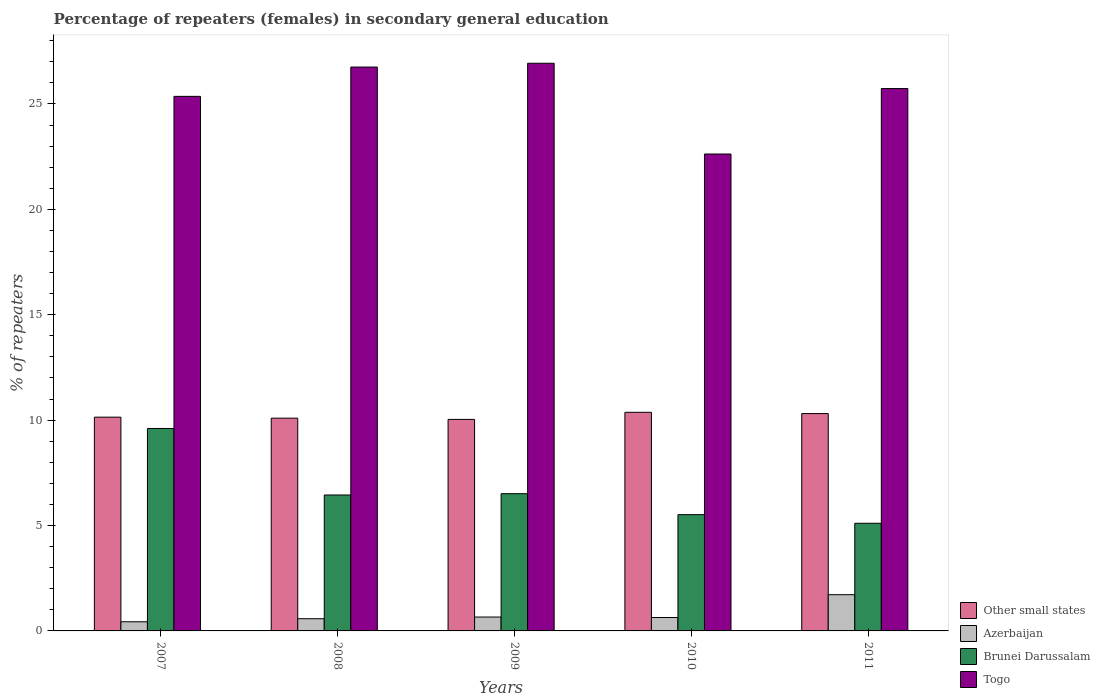How many groups of bars are there?
Ensure brevity in your answer.  5. Are the number of bars per tick equal to the number of legend labels?
Ensure brevity in your answer.  Yes. How many bars are there on the 1st tick from the left?
Offer a very short reply. 4. How many bars are there on the 2nd tick from the right?
Give a very brief answer. 4. In how many cases, is the number of bars for a given year not equal to the number of legend labels?
Offer a very short reply. 0. What is the percentage of female repeaters in Brunei Darussalam in 2009?
Your answer should be compact. 6.51. Across all years, what is the maximum percentage of female repeaters in Other small states?
Provide a succinct answer. 10.37. Across all years, what is the minimum percentage of female repeaters in Other small states?
Your answer should be very brief. 10.03. In which year was the percentage of female repeaters in Other small states minimum?
Ensure brevity in your answer.  2009. What is the total percentage of female repeaters in Azerbaijan in the graph?
Your response must be concise. 4.03. What is the difference between the percentage of female repeaters in Other small states in 2007 and that in 2010?
Keep it short and to the point. -0.23. What is the difference between the percentage of female repeaters in Togo in 2011 and the percentage of female repeaters in Azerbaijan in 2007?
Offer a terse response. 25.3. What is the average percentage of female repeaters in Other small states per year?
Your answer should be compact. 10.19. In the year 2008, what is the difference between the percentage of female repeaters in Other small states and percentage of female repeaters in Azerbaijan?
Make the answer very short. 9.51. What is the ratio of the percentage of female repeaters in Azerbaijan in 2007 to that in 2011?
Your answer should be compact. 0.25. Is the difference between the percentage of female repeaters in Other small states in 2008 and 2009 greater than the difference between the percentage of female repeaters in Azerbaijan in 2008 and 2009?
Provide a short and direct response. Yes. What is the difference between the highest and the second highest percentage of female repeaters in Azerbaijan?
Provide a short and direct response. 1.06. What is the difference between the highest and the lowest percentage of female repeaters in Other small states?
Offer a terse response. 0.34. Is the sum of the percentage of female repeaters in Azerbaijan in 2009 and 2011 greater than the maximum percentage of female repeaters in Togo across all years?
Offer a terse response. No. Is it the case that in every year, the sum of the percentage of female repeaters in Togo and percentage of female repeaters in Other small states is greater than the sum of percentage of female repeaters in Brunei Darussalam and percentage of female repeaters in Azerbaijan?
Your response must be concise. Yes. What does the 4th bar from the left in 2009 represents?
Provide a succinct answer. Togo. What does the 3rd bar from the right in 2007 represents?
Your answer should be very brief. Azerbaijan. Is it the case that in every year, the sum of the percentage of female repeaters in Other small states and percentage of female repeaters in Azerbaijan is greater than the percentage of female repeaters in Togo?
Provide a short and direct response. No. What is the difference between two consecutive major ticks on the Y-axis?
Make the answer very short. 5. Does the graph contain any zero values?
Offer a very short reply. No. Where does the legend appear in the graph?
Your answer should be very brief. Bottom right. How many legend labels are there?
Give a very brief answer. 4. How are the legend labels stacked?
Keep it short and to the point. Vertical. What is the title of the graph?
Your answer should be compact. Percentage of repeaters (females) in secondary general education. Does "Guatemala" appear as one of the legend labels in the graph?
Give a very brief answer. No. What is the label or title of the X-axis?
Make the answer very short. Years. What is the label or title of the Y-axis?
Ensure brevity in your answer.  % of repeaters. What is the % of repeaters in Other small states in 2007?
Your answer should be compact. 10.14. What is the % of repeaters of Azerbaijan in 2007?
Provide a short and direct response. 0.43. What is the % of repeaters in Brunei Darussalam in 2007?
Offer a terse response. 9.6. What is the % of repeaters in Togo in 2007?
Keep it short and to the point. 25.36. What is the % of repeaters of Other small states in 2008?
Your answer should be very brief. 10.09. What is the % of repeaters in Azerbaijan in 2008?
Offer a very short reply. 0.58. What is the % of repeaters in Brunei Darussalam in 2008?
Give a very brief answer. 6.45. What is the % of repeaters in Togo in 2008?
Offer a very short reply. 26.75. What is the % of repeaters of Other small states in 2009?
Your answer should be very brief. 10.03. What is the % of repeaters in Azerbaijan in 2009?
Your answer should be very brief. 0.66. What is the % of repeaters in Brunei Darussalam in 2009?
Your response must be concise. 6.51. What is the % of repeaters in Togo in 2009?
Your answer should be very brief. 26.93. What is the % of repeaters of Other small states in 2010?
Your answer should be compact. 10.37. What is the % of repeaters in Azerbaijan in 2010?
Provide a succinct answer. 0.64. What is the % of repeaters in Brunei Darussalam in 2010?
Make the answer very short. 5.52. What is the % of repeaters in Togo in 2010?
Your response must be concise. 22.62. What is the % of repeaters of Other small states in 2011?
Offer a very short reply. 10.31. What is the % of repeaters of Azerbaijan in 2011?
Provide a short and direct response. 1.72. What is the % of repeaters in Brunei Darussalam in 2011?
Keep it short and to the point. 5.11. What is the % of repeaters in Togo in 2011?
Give a very brief answer. 25.73. Across all years, what is the maximum % of repeaters in Other small states?
Give a very brief answer. 10.37. Across all years, what is the maximum % of repeaters in Azerbaijan?
Give a very brief answer. 1.72. Across all years, what is the maximum % of repeaters in Brunei Darussalam?
Provide a succinct answer. 9.6. Across all years, what is the maximum % of repeaters in Togo?
Your response must be concise. 26.93. Across all years, what is the minimum % of repeaters of Other small states?
Offer a terse response. 10.03. Across all years, what is the minimum % of repeaters of Azerbaijan?
Your answer should be very brief. 0.43. Across all years, what is the minimum % of repeaters of Brunei Darussalam?
Provide a succinct answer. 5.11. Across all years, what is the minimum % of repeaters in Togo?
Make the answer very short. 22.62. What is the total % of repeaters in Other small states in the graph?
Offer a very short reply. 50.95. What is the total % of repeaters of Azerbaijan in the graph?
Provide a succinct answer. 4.03. What is the total % of repeaters in Brunei Darussalam in the graph?
Provide a succinct answer. 33.19. What is the total % of repeaters of Togo in the graph?
Provide a short and direct response. 127.39. What is the difference between the % of repeaters in Other small states in 2007 and that in 2008?
Your answer should be very brief. 0.05. What is the difference between the % of repeaters of Azerbaijan in 2007 and that in 2008?
Ensure brevity in your answer.  -0.15. What is the difference between the % of repeaters of Brunei Darussalam in 2007 and that in 2008?
Your answer should be very brief. 3.16. What is the difference between the % of repeaters in Togo in 2007 and that in 2008?
Offer a terse response. -1.39. What is the difference between the % of repeaters of Other small states in 2007 and that in 2009?
Offer a terse response. 0.11. What is the difference between the % of repeaters in Azerbaijan in 2007 and that in 2009?
Give a very brief answer. -0.22. What is the difference between the % of repeaters of Brunei Darussalam in 2007 and that in 2009?
Offer a very short reply. 3.09. What is the difference between the % of repeaters of Togo in 2007 and that in 2009?
Your answer should be very brief. -1.57. What is the difference between the % of repeaters in Other small states in 2007 and that in 2010?
Your response must be concise. -0.23. What is the difference between the % of repeaters of Azerbaijan in 2007 and that in 2010?
Offer a terse response. -0.2. What is the difference between the % of repeaters in Brunei Darussalam in 2007 and that in 2010?
Keep it short and to the point. 4.09. What is the difference between the % of repeaters in Togo in 2007 and that in 2010?
Your answer should be compact. 2.73. What is the difference between the % of repeaters of Other small states in 2007 and that in 2011?
Provide a succinct answer. -0.17. What is the difference between the % of repeaters of Azerbaijan in 2007 and that in 2011?
Your answer should be compact. -1.28. What is the difference between the % of repeaters in Brunei Darussalam in 2007 and that in 2011?
Ensure brevity in your answer.  4.5. What is the difference between the % of repeaters in Togo in 2007 and that in 2011?
Offer a terse response. -0.37. What is the difference between the % of repeaters in Other small states in 2008 and that in 2009?
Offer a very short reply. 0.06. What is the difference between the % of repeaters in Azerbaijan in 2008 and that in 2009?
Your answer should be very brief. -0.08. What is the difference between the % of repeaters in Brunei Darussalam in 2008 and that in 2009?
Give a very brief answer. -0.06. What is the difference between the % of repeaters of Togo in 2008 and that in 2009?
Provide a short and direct response. -0.18. What is the difference between the % of repeaters of Other small states in 2008 and that in 2010?
Ensure brevity in your answer.  -0.28. What is the difference between the % of repeaters of Azerbaijan in 2008 and that in 2010?
Give a very brief answer. -0.06. What is the difference between the % of repeaters in Brunei Darussalam in 2008 and that in 2010?
Offer a terse response. 0.93. What is the difference between the % of repeaters of Togo in 2008 and that in 2010?
Provide a short and direct response. 4.12. What is the difference between the % of repeaters of Other small states in 2008 and that in 2011?
Keep it short and to the point. -0.22. What is the difference between the % of repeaters of Azerbaijan in 2008 and that in 2011?
Offer a terse response. -1.14. What is the difference between the % of repeaters of Brunei Darussalam in 2008 and that in 2011?
Keep it short and to the point. 1.34. What is the difference between the % of repeaters of Togo in 2008 and that in 2011?
Offer a terse response. 1.02. What is the difference between the % of repeaters in Other small states in 2009 and that in 2010?
Keep it short and to the point. -0.34. What is the difference between the % of repeaters of Azerbaijan in 2009 and that in 2010?
Provide a succinct answer. 0.02. What is the difference between the % of repeaters of Brunei Darussalam in 2009 and that in 2010?
Keep it short and to the point. 0.99. What is the difference between the % of repeaters in Togo in 2009 and that in 2010?
Keep it short and to the point. 4.31. What is the difference between the % of repeaters in Other small states in 2009 and that in 2011?
Your response must be concise. -0.28. What is the difference between the % of repeaters in Azerbaijan in 2009 and that in 2011?
Offer a terse response. -1.06. What is the difference between the % of repeaters in Brunei Darussalam in 2009 and that in 2011?
Offer a very short reply. 1.4. What is the difference between the % of repeaters in Other small states in 2010 and that in 2011?
Ensure brevity in your answer.  0.06. What is the difference between the % of repeaters in Azerbaijan in 2010 and that in 2011?
Offer a very short reply. -1.08. What is the difference between the % of repeaters in Brunei Darussalam in 2010 and that in 2011?
Your answer should be compact. 0.41. What is the difference between the % of repeaters in Togo in 2010 and that in 2011?
Keep it short and to the point. -3.11. What is the difference between the % of repeaters of Other small states in 2007 and the % of repeaters of Azerbaijan in 2008?
Ensure brevity in your answer.  9.56. What is the difference between the % of repeaters in Other small states in 2007 and the % of repeaters in Brunei Darussalam in 2008?
Keep it short and to the point. 3.69. What is the difference between the % of repeaters of Other small states in 2007 and the % of repeaters of Togo in 2008?
Provide a succinct answer. -16.61. What is the difference between the % of repeaters of Azerbaijan in 2007 and the % of repeaters of Brunei Darussalam in 2008?
Offer a terse response. -6.01. What is the difference between the % of repeaters in Azerbaijan in 2007 and the % of repeaters in Togo in 2008?
Provide a succinct answer. -26.32. What is the difference between the % of repeaters of Brunei Darussalam in 2007 and the % of repeaters of Togo in 2008?
Keep it short and to the point. -17.15. What is the difference between the % of repeaters of Other small states in 2007 and the % of repeaters of Azerbaijan in 2009?
Give a very brief answer. 9.48. What is the difference between the % of repeaters of Other small states in 2007 and the % of repeaters of Brunei Darussalam in 2009?
Provide a short and direct response. 3.63. What is the difference between the % of repeaters of Other small states in 2007 and the % of repeaters of Togo in 2009?
Your response must be concise. -16.79. What is the difference between the % of repeaters of Azerbaijan in 2007 and the % of repeaters of Brunei Darussalam in 2009?
Offer a terse response. -6.08. What is the difference between the % of repeaters of Azerbaijan in 2007 and the % of repeaters of Togo in 2009?
Offer a terse response. -26.5. What is the difference between the % of repeaters of Brunei Darussalam in 2007 and the % of repeaters of Togo in 2009?
Your answer should be compact. -17.33. What is the difference between the % of repeaters in Other small states in 2007 and the % of repeaters in Azerbaijan in 2010?
Provide a succinct answer. 9.5. What is the difference between the % of repeaters in Other small states in 2007 and the % of repeaters in Brunei Darussalam in 2010?
Offer a very short reply. 4.62. What is the difference between the % of repeaters of Other small states in 2007 and the % of repeaters of Togo in 2010?
Give a very brief answer. -12.48. What is the difference between the % of repeaters in Azerbaijan in 2007 and the % of repeaters in Brunei Darussalam in 2010?
Offer a terse response. -5.08. What is the difference between the % of repeaters in Azerbaijan in 2007 and the % of repeaters in Togo in 2010?
Offer a terse response. -22.19. What is the difference between the % of repeaters of Brunei Darussalam in 2007 and the % of repeaters of Togo in 2010?
Provide a succinct answer. -13.02. What is the difference between the % of repeaters in Other small states in 2007 and the % of repeaters in Azerbaijan in 2011?
Give a very brief answer. 8.42. What is the difference between the % of repeaters of Other small states in 2007 and the % of repeaters of Brunei Darussalam in 2011?
Ensure brevity in your answer.  5.03. What is the difference between the % of repeaters in Other small states in 2007 and the % of repeaters in Togo in 2011?
Keep it short and to the point. -15.59. What is the difference between the % of repeaters in Azerbaijan in 2007 and the % of repeaters in Brunei Darussalam in 2011?
Keep it short and to the point. -4.67. What is the difference between the % of repeaters in Azerbaijan in 2007 and the % of repeaters in Togo in 2011?
Offer a very short reply. -25.3. What is the difference between the % of repeaters in Brunei Darussalam in 2007 and the % of repeaters in Togo in 2011?
Offer a very short reply. -16.13. What is the difference between the % of repeaters in Other small states in 2008 and the % of repeaters in Azerbaijan in 2009?
Provide a succinct answer. 9.44. What is the difference between the % of repeaters in Other small states in 2008 and the % of repeaters in Brunei Darussalam in 2009?
Offer a terse response. 3.58. What is the difference between the % of repeaters of Other small states in 2008 and the % of repeaters of Togo in 2009?
Offer a terse response. -16.84. What is the difference between the % of repeaters in Azerbaijan in 2008 and the % of repeaters in Brunei Darussalam in 2009?
Make the answer very short. -5.93. What is the difference between the % of repeaters in Azerbaijan in 2008 and the % of repeaters in Togo in 2009?
Offer a very short reply. -26.35. What is the difference between the % of repeaters in Brunei Darussalam in 2008 and the % of repeaters in Togo in 2009?
Offer a terse response. -20.48. What is the difference between the % of repeaters in Other small states in 2008 and the % of repeaters in Azerbaijan in 2010?
Your answer should be very brief. 9.46. What is the difference between the % of repeaters of Other small states in 2008 and the % of repeaters of Brunei Darussalam in 2010?
Give a very brief answer. 4.58. What is the difference between the % of repeaters of Other small states in 2008 and the % of repeaters of Togo in 2010?
Offer a terse response. -12.53. What is the difference between the % of repeaters of Azerbaijan in 2008 and the % of repeaters of Brunei Darussalam in 2010?
Ensure brevity in your answer.  -4.94. What is the difference between the % of repeaters of Azerbaijan in 2008 and the % of repeaters of Togo in 2010?
Your answer should be very brief. -22.05. What is the difference between the % of repeaters of Brunei Darussalam in 2008 and the % of repeaters of Togo in 2010?
Your answer should be very brief. -16.18. What is the difference between the % of repeaters of Other small states in 2008 and the % of repeaters of Azerbaijan in 2011?
Ensure brevity in your answer.  8.38. What is the difference between the % of repeaters in Other small states in 2008 and the % of repeaters in Brunei Darussalam in 2011?
Ensure brevity in your answer.  4.99. What is the difference between the % of repeaters in Other small states in 2008 and the % of repeaters in Togo in 2011?
Your answer should be compact. -15.64. What is the difference between the % of repeaters of Azerbaijan in 2008 and the % of repeaters of Brunei Darussalam in 2011?
Your answer should be compact. -4.53. What is the difference between the % of repeaters in Azerbaijan in 2008 and the % of repeaters in Togo in 2011?
Give a very brief answer. -25.15. What is the difference between the % of repeaters in Brunei Darussalam in 2008 and the % of repeaters in Togo in 2011?
Your answer should be compact. -19.28. What is the difference between the % of repeaters in Other small states in 2009 and the % of repeaters in Azerbaijan in 2010?
Keep it short and to the point. 9.4. What is the difference between the % of repeaters in Other small states in 2009 and the % of repeaters in Brunei Darussalam in 2010?
Provide a succinct answer. 4.52. What is the difference between the % of repeaters in Other small states in 2009 and the % of repeaters in Togo in 2010?
Offer a terse response. -12.59. What is the difference between the % of repeaters in Azerbaijan in 2009 and the % of repeaters in Brunei Darussalam in 2010?
Provide a short and direct response. -4.86. What is the difference between the % of repeaters of Azerbaijan in 2009 and the % of repeaters of Togo in 2010?
Keep it short and to the point. -21.97. What is the difference between the % of repeaters in Brunei Darussalam in 2009 and the % of repeaters in Togo in 2010?
Offer a terse response. -16.11. What is the difference between the % of repeaters of Other small states in 2009 and the % of repeaters of Azerbaijan in 2011?
Provide a succinct answer. 8.32. What is the difference between the % of repeaters in Other small states in 2009 and the % of repeaters in Brunei Darussalam in 2011?
Offer a very short reply. 4.93. What is the difference between the % of repeaters in Other small states in 2009 and the % of repeaters in Togo in 2011?
Your answer should be very brief. -15.7. What is the difference between the % of repeaters in Azerbaijan in 2009 and the % of repeaters in Brunei Darussalam in 2011?
Give a very brief answer. -4.45. What is the difference between the % of repeaters in Azerbaijan in 2009 and the % of repeaters in Togo in 2011?
Your answer should be compact. -25.07. What is the difference between the % of repeaters in Brunei Darussalam in 2009 and the % of repeaters in Togo in 2011?
Your response must be concise. -19.22. What is the difference between the % of repeaters in Other small states in 2010 and the % of repeaters in Azerbaijan in 2011?
Ensure brevity in your answer.  8.65. What is the difference between the % of repeaters in Other small states in 2010 and the % of repeaters in Brunei Darussalam in 2011?
Keep it short and to the point. 5.26. What is the difference between the % of repeaters in Other small states in 2010 and the % of repeaters in Togo in 2011?
Provide a short and direct response. -15.36. What is the difference between the % of repeaters of Azerbaijan in 2010 and the % of repeaters of Brunei Darussalam in 2011?
Your answer should be compact. -4.47. What is the difference between the % of repeaters in Azerbaijan in 2010 and the % of repeaters in Togo in 2011?
Your response must be concise. -25.09. What is the difference between the % of repeaters of Brunei Darussalam in 2010 and the % of repeaters of Togo in 2011?
Provide a short and direct response. -20.21. What is the average % of repeaters in Other small states per year?
Ensure brevity in your answer.  10.19. What is the average % of repeaters of Azerbaijan per year?
Your answer should be compact. 0.81. What is the average % of repeaters of Brunei Darussalam per year?
Provide a short and direct response. 6.64. What is the average % of repeaters in Togo per year?
Provide a succinct answer. 25.48. In the year 2007, what is the difference between the % of repeaters of Other small states and % of repeaters of Azerbaijan?
Your response must be concise. 9.71. In the year 2007, what is the difference between the % of repeaters in Other small states and % of repeaters in Brunei Darussalam?
Keep it short and to the point. 0.54. In the year 2007, what is the difference between the % of repeaters of Other small states and % of repeaters of Togo?
Offer a very short reply. -15.22. In the year 2007, what is the difference between the % of repeaters of Azerbaijan and % of repeaters of Brunei Darussalam?
Make the answer very short. -9.17. In the year 2007, what is the difference between the % of repeaters of Azerbaijan and % of repeaters of Togo?
Offer a very short reply. -24.92. In the year 2007, what is the difference between the % of repeaters of Brunei Darussalam and % of repeaters of Togo?
Provide a succinct answer. -15.76. In the year 2008, what is the difference between the % of repeaters in Other small states and % of repeaters in Azerbaijan?
Offer a very short reply. 9.51. In the year 2008, what is the difference between the % of repeaters in Other small states and % of repeaters in Brunei Darussalam?
Your answer should be compact. 3.65. In the year 2008, what is the difference between the % of repeaters in Other small states and % of repeaters in Togo?
Give a very brief answer. -16.66. In the year 2008, what is the difference between the % of repeaters in Azerbaijan and % of repeaters in Brunei Darussalam?
Offer a very short reply. -5.87. In the year 2008, what is the difference between the % of repeaters of Azerbaijan and % of repeaters of Togo?
Your answer should be compact. -26.17. In the year 2008, what is the difference between the % of repeaters in Brunei Darussalam and % of repeaters in Togo?
Provide a succinct answer. -20.3. In the year 2009, what is the difference between the % of repeaters of Other small states and % of repeaters of Azerbaijan?
Give a very brief answer. 9.38. In the year 2009, what is the difference between the % of repeaters of Other small states and % of repeaters of Brunei Darussalam?
Your answer should be compact. 3.52. In the year 2009, what is the difference between the % of repeaters of Other small states and % of repeaters of Togo?
Ensure brevity in your answer.  -16.9. In the year 2009, what is the difference between the % of repeaters in Azerbaijan and % of repeaters in Brunei Darussalam?
Offer a terse response. -5.85. In the year 2009, what is the difference between the % of repeaters of Azerbaijan and % of repeaters of Togo?
Your answer should be very brief. -26.27. In the year 2009, what is the difference between the % of repeaters in Brunei Darussalam and % of repeaters in Togo?
Ensure brevity in your answer.  -20.42. In the year 2010, what is the difference between the % of repeaters in Other small states and % of repeaters in Azerbaijan?
Provide a succinct answer. 9.73. In the year 2010, what is the difference between the % of repeaters of Other small states and % of repeaters of Brunei Darussalam?
Give a very brief answer. 4.86. In the year 2010, what is the difference between the % of repeaters in Other small states and % of repeaters in Togo?
Offer a terse response. -12.25. In the year 2010, what is the difference between the % of repeaters of Azerbaijan and % of repeaters of Brunei Darussalam?
Provide a succinct answer. -4.88. In the year 2010, what is the difference between the % of repeaters of Azerbaijan and % of repeaters of Togo?
Your answer should be very brief. -21.99. In the year 2010, what is the difference between the % of repeaters of Brunei Darussalam and % of repeaters of Togo?
Offer a terse response. -17.11. In the year 2011, what is the difference between the % of repeaters of Other small states and % of repeaters of Azerbaijan?
Your answer should be very brief. 8.59. In the year 2011, what is the difference between the % of repeaters in Other small states and % of repeaters in Brunei Darussalam?
Your response must be concise. 5.2. In the year 2011, what is the difference between the % of repeaters of Other small states and % of repeaters of Togo?
Ensure brevity in your answer.  -15.42. In the year 2011, what is the difference between the % of repeaters of Azerbaijan and % of repeaters of Brunei Darussalam?
Ensure brevity in your answer.  -3.39. In the year 2011, what is the difference between the % of repeaters in Azerbaijan and % of repeaters in Togo?
Provide a short and direct response. -24.01. In the year 2011, what is the difference between the % of repeaters in Brunei Darussalam and % of repeaters in Togo?
Keep it short and to the point. -20.62. What is the ratio of the % of repeaters in Azerbaijan in 2007 to that in 2008?
Offer a very short reply. 0.75. What is the ratio of the % of repeaters in Brunei Darussalam in 2007 to that in 2008?
Your answer should be very brief. 1.49. What is the ratio of the % of repeaters of Togo in 2007 to that in 2008?
Provide a short and direct response. 0.95. What is the ratio of the % of repeaters of Other small states in 2007 to that in 2009?
Provide a succinct answer. 1.01. What is the ratio of the % of repeaters of Azerbaijan in 2007 to that in 2009?
Give a very brief answer. 0.66. What is the ratio of the % of repeaters in Brunei Darussalam in 2007 to that in 2009?
Provide a short and direct response. 1.48. What is the ratio of the % of repeaters of Togo in 2007 to that in 2009?
Make the answer very short. 0.94. What is the ratio of the % of repeaters of Other small states in 2007 to that in 2010?
Offer a very short reply. 0.98. What is the ratio of the % of repeaters of Azerbaijan in 2007 to that in 2010?
Your answer should be very brief. 0.68. What is the ratio of the % of repeaters of Brunei Darussalam in 2007 to that in 2010?
Make the answer very short. 1.74. What is the ratio of the % of repeaters in Togo in 2007 to that in 2010?
Ensure brevity in your answer.  1.12. What is the ratio of the % of repeaters in Other small states in 2007 to that in 2011?
Offer a very short reply. 0.98. What is the ratio of the % of repeaters of Azerbaijan in 2007 to that in 2011?
Keep it short and to the point. 0.25. What is the ratio of the % of repeaters of Brunei Darussalam in 2007 to that in 2011?
Provide a succinct answer. 1.88. What is the ratio of the % of repeaters in Togo in 2007 to that in 2011?
Make the answer very short. 0.99. What is the ratio of the % of repeaters in Other small states in 2008 to that in 2009?
Your answer should be very brief. 1.01. What is the ratio of the % of repeaters in Azerbaijan in 2008 to that in 2009?
Offer a terse response. 0.88. What is the ratio of the % of repeaters in Brunei Darussalam in 2008 to that in 2009?
Provide a succinct answer. 0.99. What is the ratio of the % of repeaters of Togo in 2008 to that in 2009?
Offer a terse response. 0.99. What is the ratio of the % of repeaters in Other small states in 2008 to that in 2010?
Provide a short and direct response. 0.97. What is the ratio of the % of repeaters of Azerbaijan in 2008 to that in 2010?
Provide a succinct answer. 0.91. What is the ratio of the % of repeaters in Brunei Darussalam in 2008 to that in 2010?
Make the answer very short. 1.17. What is the ratio of the % of repeaters of Togo in 2008 to that in 2010?
Offer a very short reply. 1.18. What is the ratio of the % of repeaters of Other small states in 2008 to that in 2011?
Your answer should be very brief. 0.98. What is the ratio of the % of repeaters in Azerbaijan in 2008 to that in 2011?
Provide a succinct answer. 0.34. What is the ratio of the % of repeaters in Brunei Darussalam in 2008 to that in 2011?
Give a very brief answer. 1.26. What is the ratio of the % of repeaters in Togo in 2008 to that in 2011?
Offer a terse response. 1.04. What is the ratio of the % of repeaters in Other small states in 2009 to that in 2010?
Give a very brief answer. 0.97. What is the ratio of the % of repeaters in Azerbaijan in 2009 to that in 2010?
Make the answer very short. 1.03. What is the ratio of the % of repeaters of Brunei Darussalam in 2009 to that in 2010?
Give a very brief answer. 1.18. What is the ratio of the % of repeaters of Togo in 2009 to that in 2010?
Provide a short and direct response. 1.19. What is the ratio of the % of repeaters of Other small states in 2009 to that in 2011?
Your response must be concise. 0.97. What is the ratio of the % of repeaters of Azerbaijan in 2009 to that in 2011?
Give a very brief answer. 0.38. What is the ratio of the % of repeaters in Brunei Darussalam in 2009 to that in 2011?
Give a very brief answer. 1.27. What is the ratio of the % of repeaters in Togo in 2009 to that in 2011?
Offer a terse response. 1.05. What is the ratio of the % of repeaters of Other small states in 2010 to that in 2011?
Make the answer very short. 1.01. What is the ratio of the % of repeaters of Azerbaijan in 2010 to that in 2011?
Make the answer very short. 0.37. What is the ratio of the % of repeaters of Brunei Darussalam in 2010 to that in 2011?
Make the answer very short. 1.08. What is the ratio of the % of repeaters of Togo in 2010 to that in 2011?
Offer a terse response. 0.88. What is the difference between the highest and the second highest % of repeaters in Other small states?
Make the answer very short. 0.06. What is the difference between the highest and the second highest % of repeaters in Azerbaijan?
Offer a terse response. 1.06. What is the difference between the highest and the second highest % of repeaters of Brunei Darussalam?
Provide a short and direct response. 3.09. What is the difference between the highest and the second highest % of repeaters of Togo?
Make the answer very short. 0.18. What is the difference between the highest and the lowest % of repeaters of Other small states?
Your response must be concise. 0.34. What is the difference between the highest and the lowest % of repeaters of Azerbaijan?
Offer a very short reply. 1.28. What is the difference between the highest and the lowest % of repeaters in Brunei Darussalam?
Your answer should be very brief. 4.5. What is the difference between the highest and the lowest % of repeaters of Togo?
Offer a terse response. 4.31. 